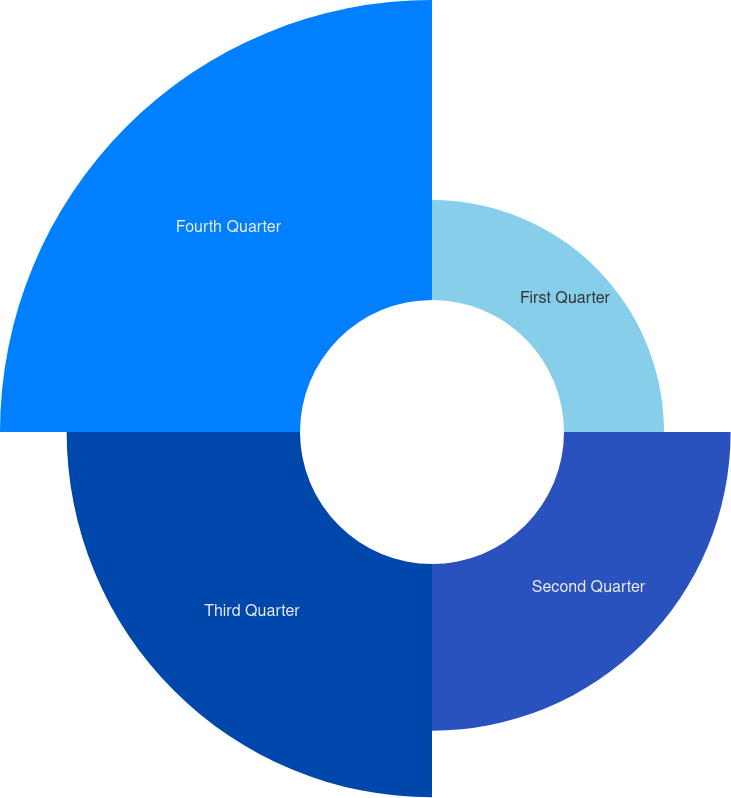Convert chart. <chart><loc_0><loc_0><loc_500><loc_500><pie_chart><fcel>First Quarter<fcel>Second Quarter<fcel>Third Quarter<fcel>Fourth Quarter<nl><fcel>12.5%<fcel>20.83%<fcel>29.17%<fcel>37.5%<nl></chart> 